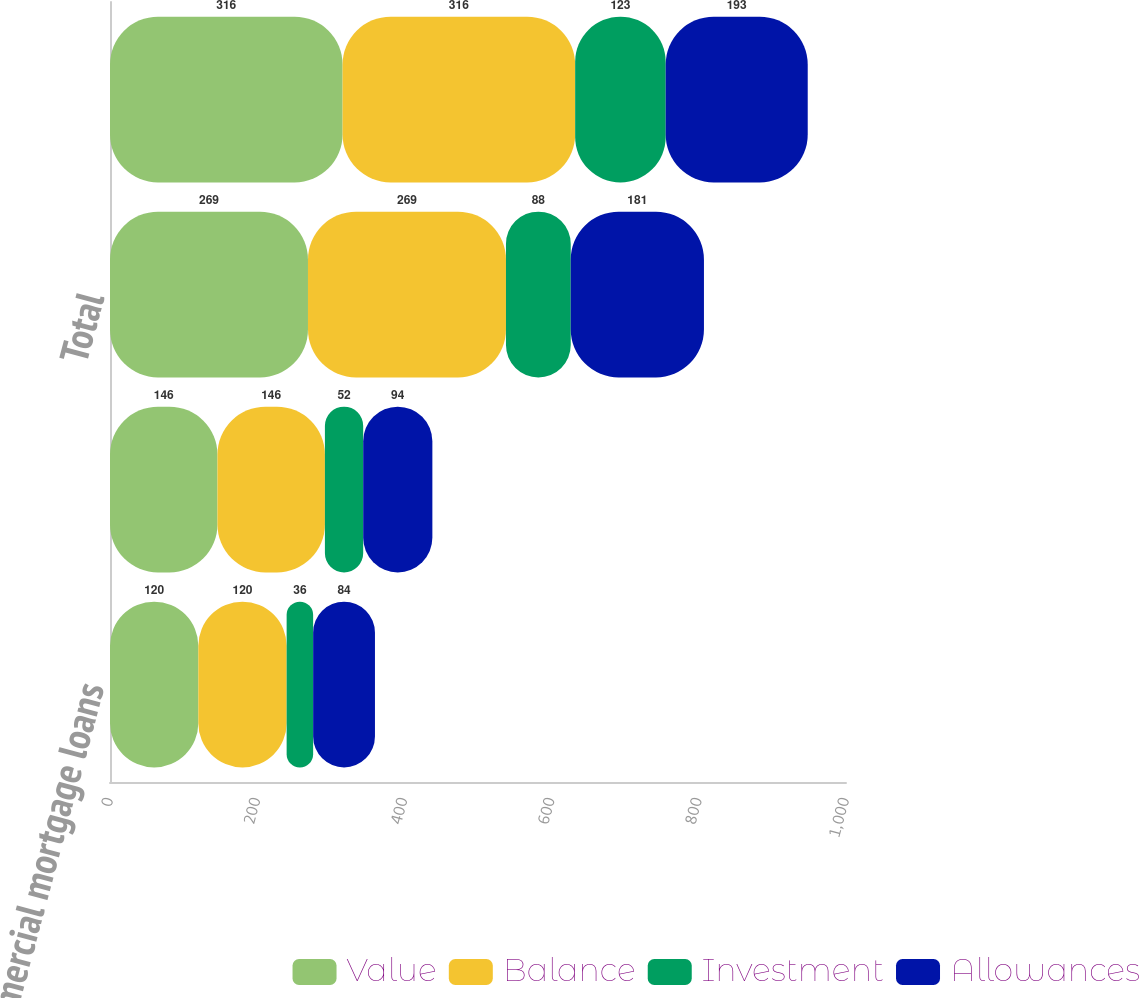<chart> <loc_0><loc_0><loc_500><loc_500><stacked_bar_chart><ecel><fcel>Commercial mortgage loans<fcel>Agricultural mortgage loans<fcel>Total<fcel>Total mortgage loans at<nl><fcel>Value<fcel>120<fcel>146<fcel>269<fcel>316<nl><fcel>Balance<fcel>120<fcel>146<fcel>269<fcel>316<nl><fcel>Investment<fcel>36<fcel>52<fcel>88<fcel>123<nl><fcel>Allowances<fcel>84<fcel>94<fcel>181<fcel>193<nl></chart> 